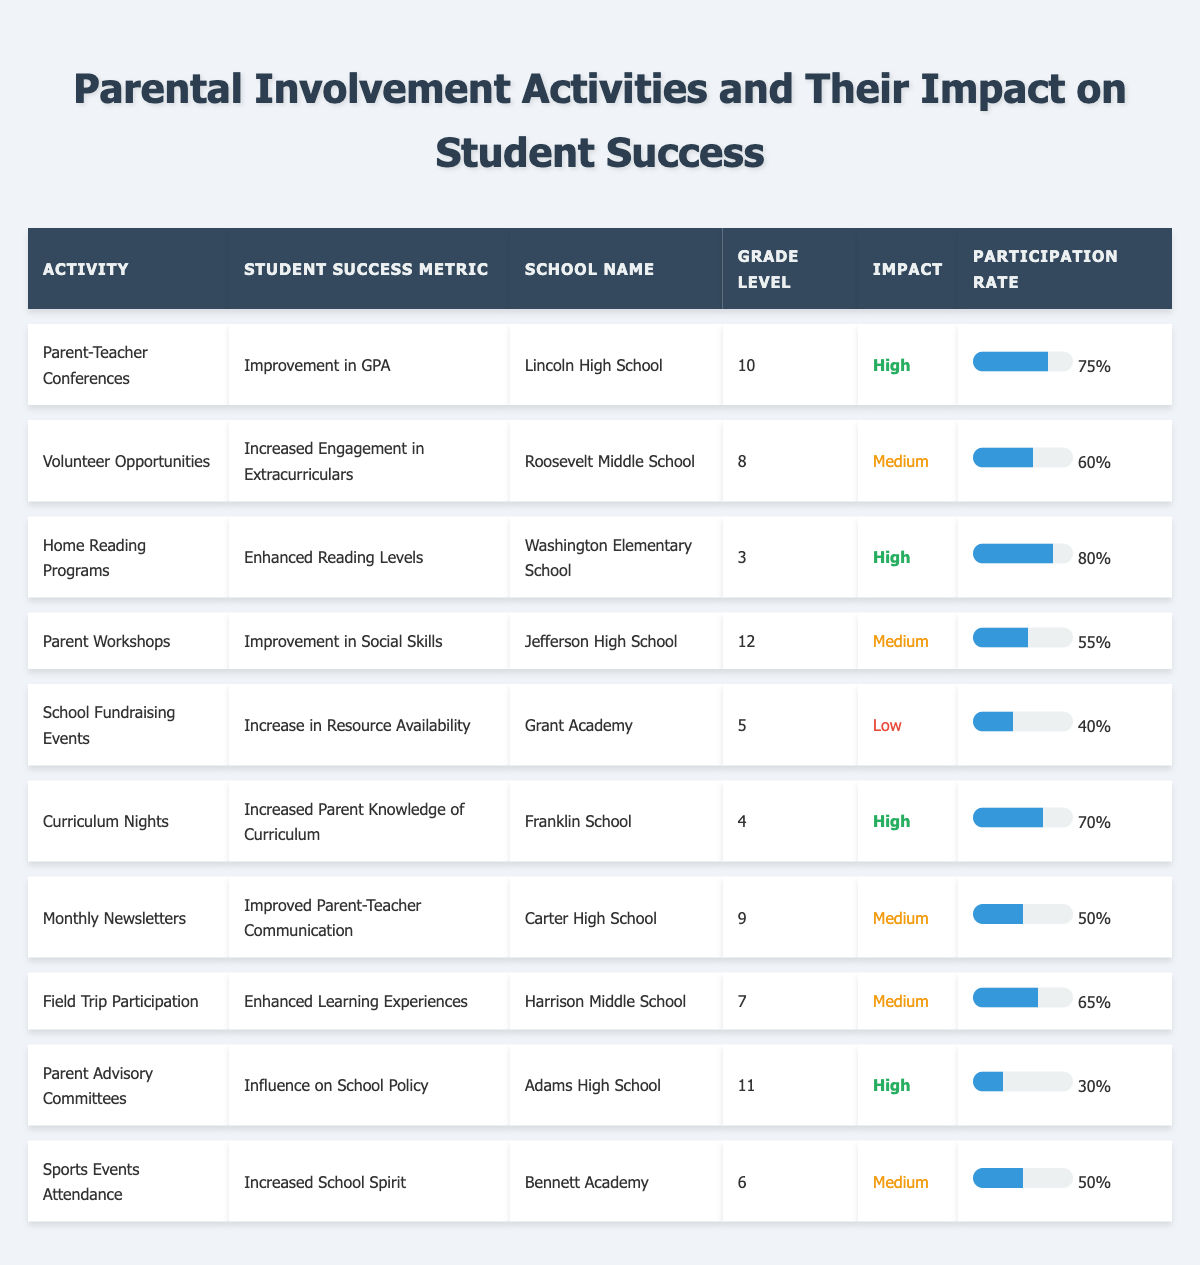What is the participation rate of Home Reading Programs? The participation rate for Home Reading Programs is listed directly in the table as 80%.
Answer: 80% Which activity has the highest impact on student success? The activities with the highest impact are Parent-Teacher Conferences, Home Reading Programs, Curriculum Nights, and Parent Advisory Committees, but Parent-Teacher Conferences and Home Reading Programs both have a "High" impact classification.
Answer: Parent-Teacher Conferences and Home Reading Programs What is the average participation rate of activities with "Medium" impact? The participation rates for activities with "Medium" impact are: 60% (Volunteer Opportunities), 55% (Parent Workshops), 50% (Monthly Newsletters), 65% (Field Trip Participation), 50% (Sports Events Attendance). The total is 60 + 55 + 50 + 65 + 50 = 280, and there are 5 activities, thus the average is 280/5 = 56%.
Answer: 56% Is the impact of School Fundraising Events classified as "High"? The impact of School Fundraising Events is classified as "Low" in the table.
Answer: No How many activities have a participation rate greater than 70%? The activities with participation rates greater than 70% are Home Reading Programs (80%) and Parent-Teacher Conferences (75%). So there are 2 activities that meet this criterion.
Answer: 2 What is the total number of "High" impact activities listed? The High impact activities are Parent-Teacher Conferences, Home Reading Programs, Curriculum Nights, and Parent Advisory Committees. That's a total of 4 activities.
Answer: 4 Which school has the lowest participation rate and what is it? Grant Academy has the lowest participation rate at 40%, as indicated in the table.
Answer: Grant Academy, 40% How does the participation rate of Parent Advisory Committees compare to that of Field Trip Participation? The participation rate of Parent Advisory Committees is 30%, while the participation rate of Field Trip Participation is 65%. Since 30% is less than 65%, Parent Advisory Committees has a lower participation rate.
Answer: Lower What is the correlation between participation rate and impact level in this data? While the data shows that activities with "High" impact generally have higher participation rates, it's not numerical correlation; it's more of a tendency, as seen in three "High" impact activities having participation rates above average, while one has a lower rate.
Answer: Positive tendency What is the difference in participation rates between the highest and lowest? The highest participation rate is 80% for Home Reading Programs and the lowest is 30% for Parent Advisory Committees. Thus, the difference is 80% - 30% = 50%.
Answer: 50% 